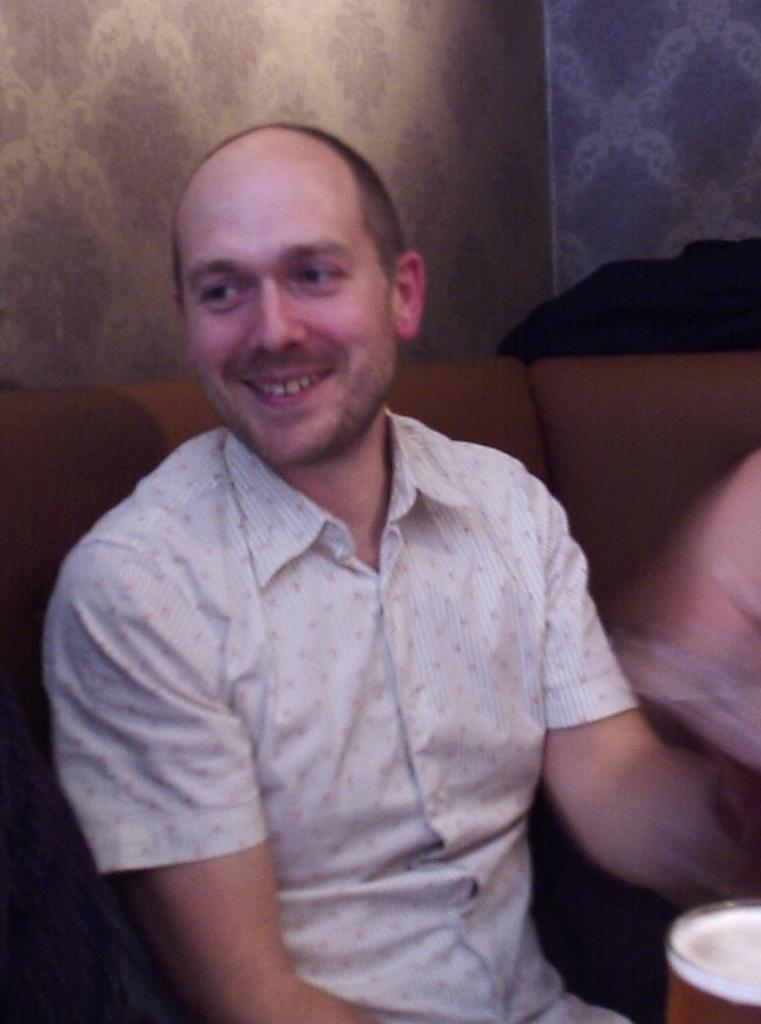What is the main subject of the image? There is a person in the image. What is the person doing in the image? The person is sitting on a sofa. What type of cup is the person holding in the image? There is no cup present in the image; the person is sitting on a sofa. Who is the person working with in the image? There is no indication of work or a partner in the image; the person is simply sitting on a sofa. 